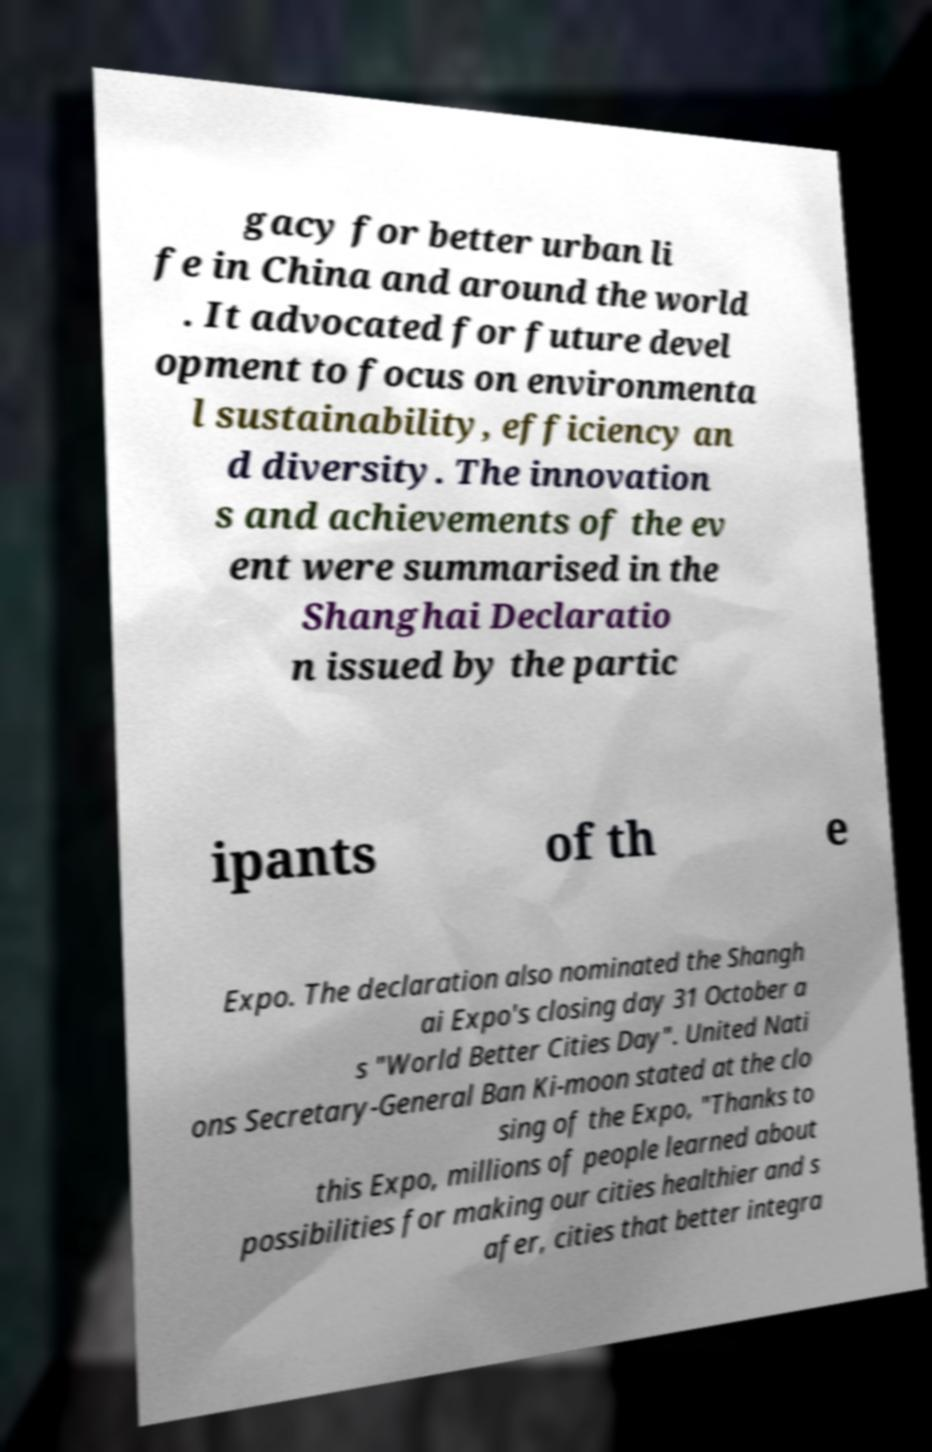Could you extract and type out the text from this image? gacy for better urban li fe in China and around the world . It advocated for future devel opment to focus on environmenta l sustainability, efficiency an d diversity. The innovation s and achievements of the ev ent were summarised in the Shanghai Declaratio n issued by the partic ipants of th e Expo. The declaration also nominated the Shangh ai Expo's closing day 31 October a s "World Better Cities Day". United Nati ons Secretary-General Ban Ki-moon stated at the clo sing of the Expo, "Thanks to this Expo, millions of people learned about possibilities for making our cities healthier and s afer, cities that better integra 